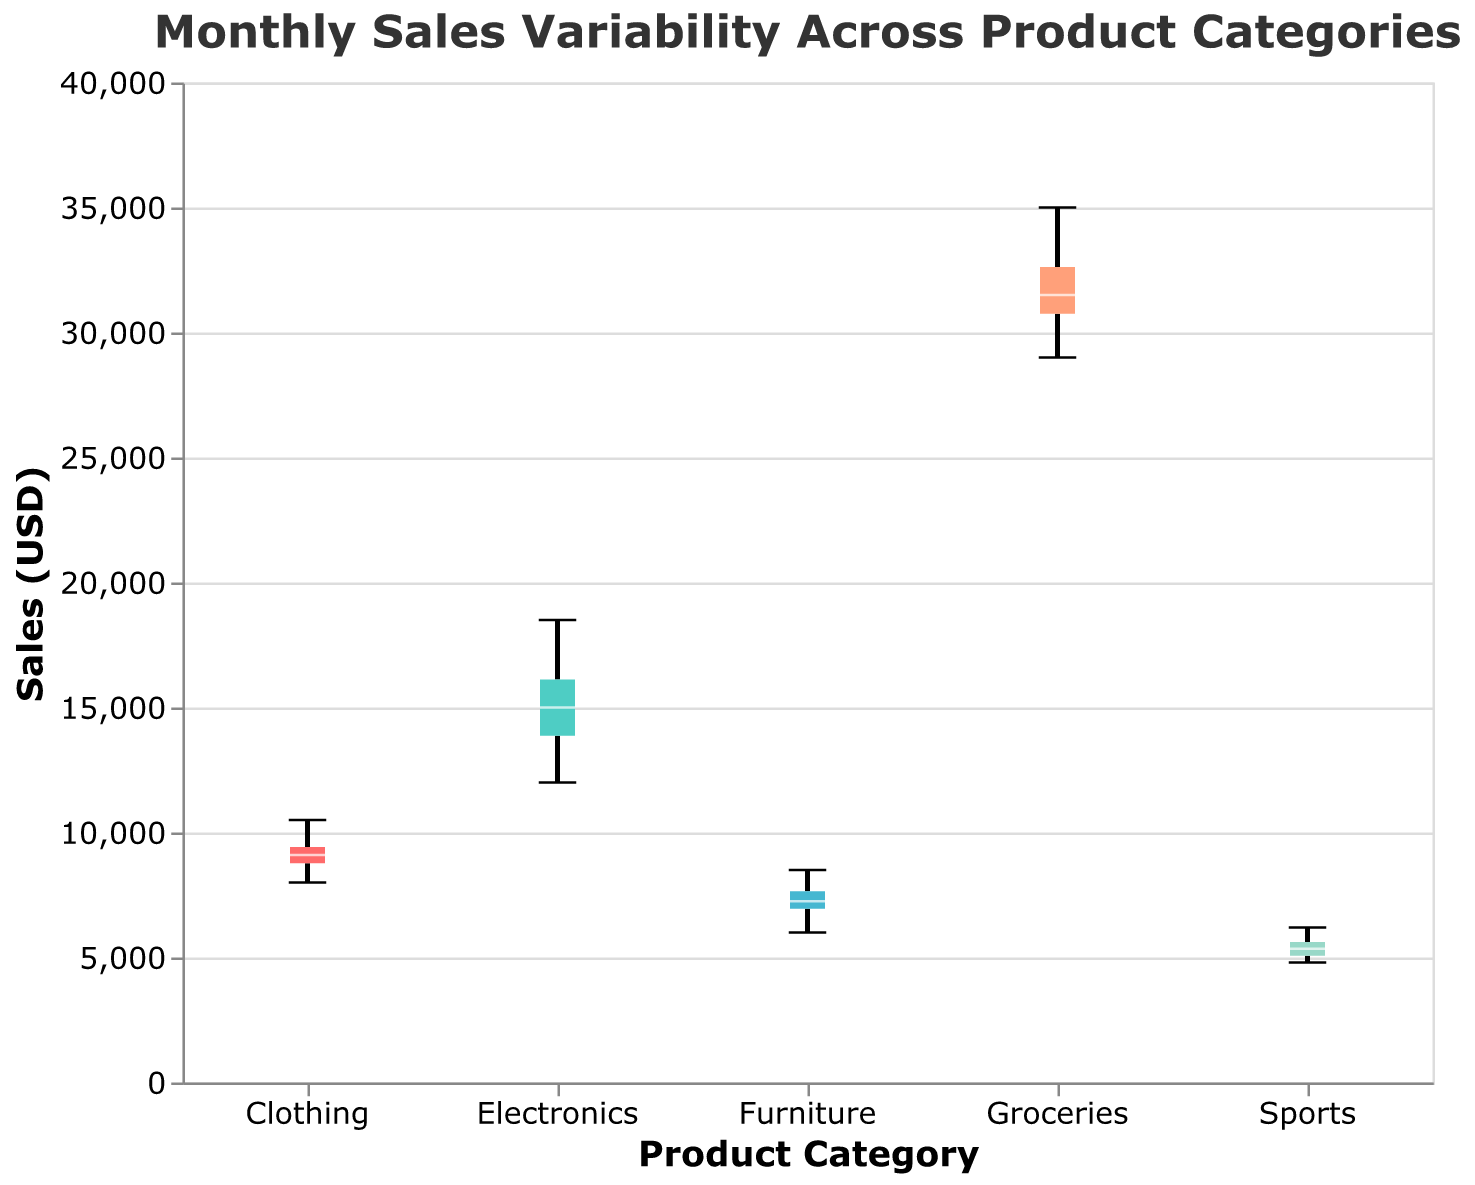What is the title of the box plot? The title is displayed at the top of the figure. It reads "Monthly Sales Variability Across Product Categories".
Answer: Monthly Sales Variability Across Product Categories What is the median sales value for the Electronics category? The median is represented by the white line within the box for the Electronics category.
Answer: 15000 Which product category has the highest maximum sales value? The maximum sales value can be determined by looking at the top whisker of each box plot. The Groceries category extends the highest.
Answer: Groceries What is the sales range (difference between maximum and minimum values) for the Sports category? The range can be calculated by subtracting the minimum value (bottom whisker) from the maximum value (top whisker) for the Sports category. 6000 (maximum) - 4800 (minimum) = 1400.
Answer: 1400 Which product category appears to have the least variability in sales? The category with the shortest box and whiskers has the least variability. This appears to be the Electronics category.
Answer: Electronics Compare the median sales values of Furniture and Clothing categories. Which is higher? Look at the white lines within the boxes for both categories; the median of the Clothing category is higher than that of the Furniture category.
Answer: Clothing What is the interquartile range (IQR) of the Groceries category? The IQR is the span of the box (the distance between the top of the lower quartile and the bottom of the upper quartile). In the case of the Groceries category, the IQR is 32500 (upper quartile) - 30000 (lower quartile) = 2500.
Answer: 2500 How do the sales values for the Furniture category vary compared to Electronics? To compare variability, look at the span of the boxes and whiskers for both categories. The Electronics category shows larger variability as it has a longer box and whiskers compared to Furniture.
Answer: Electronics has more variability What is the 75th percentile sales value for the Clothing category? The 75th percentile (upper quartile) is the top edge of the box for the Clothing category. This is around 9700.
Answer: 9700 Based on the box plot, in which month would you expect the Clothing category's sales to be closest to the median? The median is the middle line within the box for the Clothing category. The median value is around 9200, which is close to the sales in May.
Answer: May 